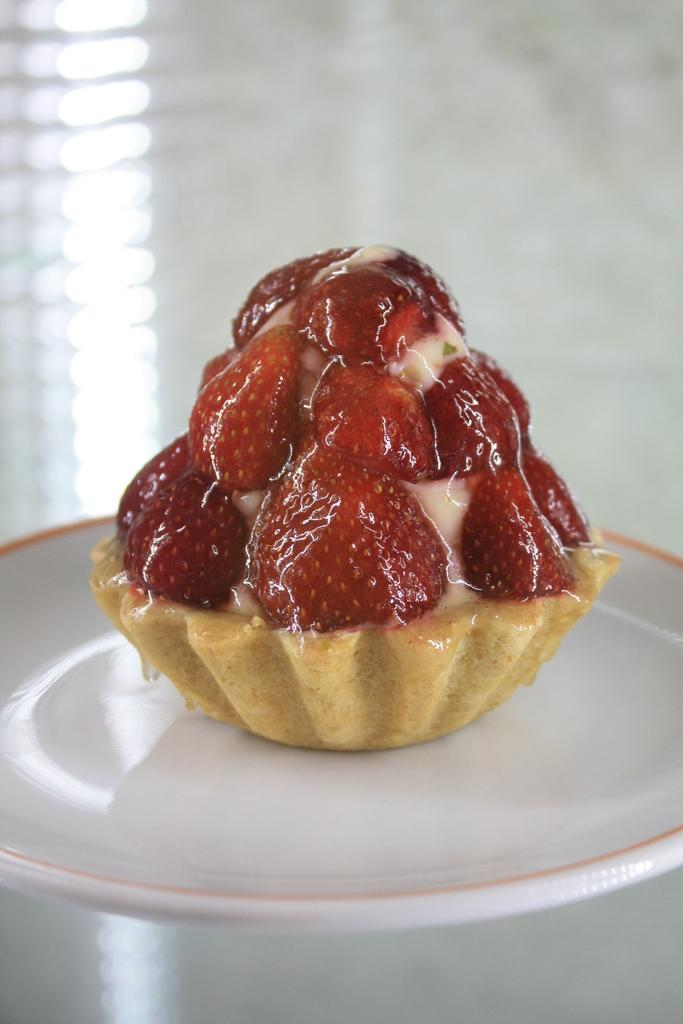What type of dessert is in the image? There is a small cupcake in the image. What is the color of the cupcake? The cupcake is brown in color. What is on top of the cupcake? The cupcake has a strawberry topping. On what is the cupcake placed? The cupcake is placed on a white plate. What songs are being sung by the beetle in the image? There is no beetle or singing in the image; it features a small brown cupcake with a strawberry topping on a white plate. 